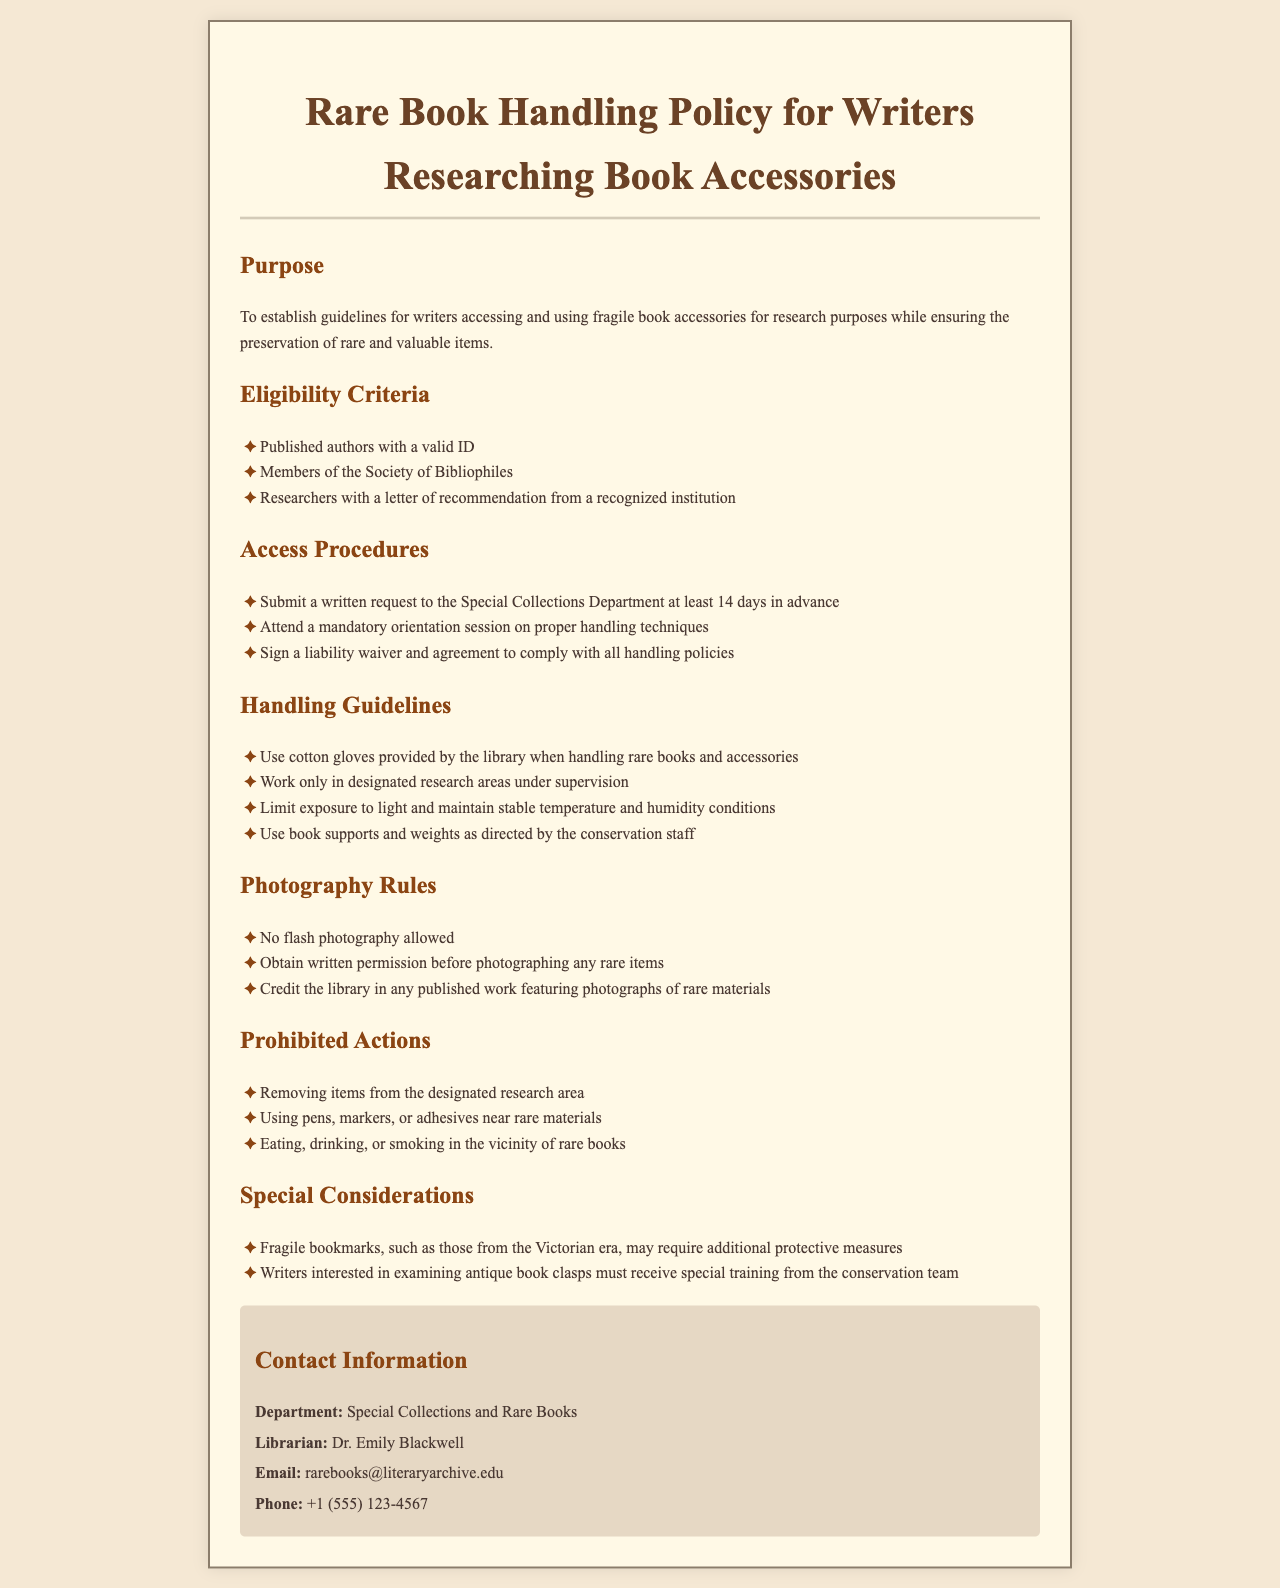What is the purpose of the policy? The purpose of the policy is to establish guidelines for writers accessing and using fragile book accessories for research purposes while ensuring the preservation of rare and valuable items.
Answer: To establish guidelines for writers accessing and using fragile book accessories for research purposes while ensuring the preservation of rare and valuable items Who must attend a mandatory orientation session? A mandatory orientation session is required for all writers wishing to handle fragile book accessories.
Answer: All writers What is the advance notice required for submitting a request? The document specifies that a written request must be submitted at least 14 days in advance.
Answer: 14 days What must writers use when handling rare books? The handling guidelines specify that users must wear cotton gloves when handling rare books and accessories.
Answer: Cotton gloves What must be obtained before photographing rare items? Photographers must obtain written permission before photographing any rare items.
Answer: Written permission Which organization’s members are eligible? Members of the Society of Bibliophiles are eligible to access fragile book accessories.
Answer: Society of Bibliophiles Is eating allowed near rare books? The policy explicitly prohibits eating near rare materials to ensure their preservation.
Answer: No What is one special consideration for examining fragile bookmarks? Fragile bookmarks, such as those from the Victorian era, may require additional protective measures.
Answer: Additional protective measures Who is the contact librarian for this policy? The contact librarian's name is provided for inquiries related to the policy.
Answer: Dr. Emily Blackwell 